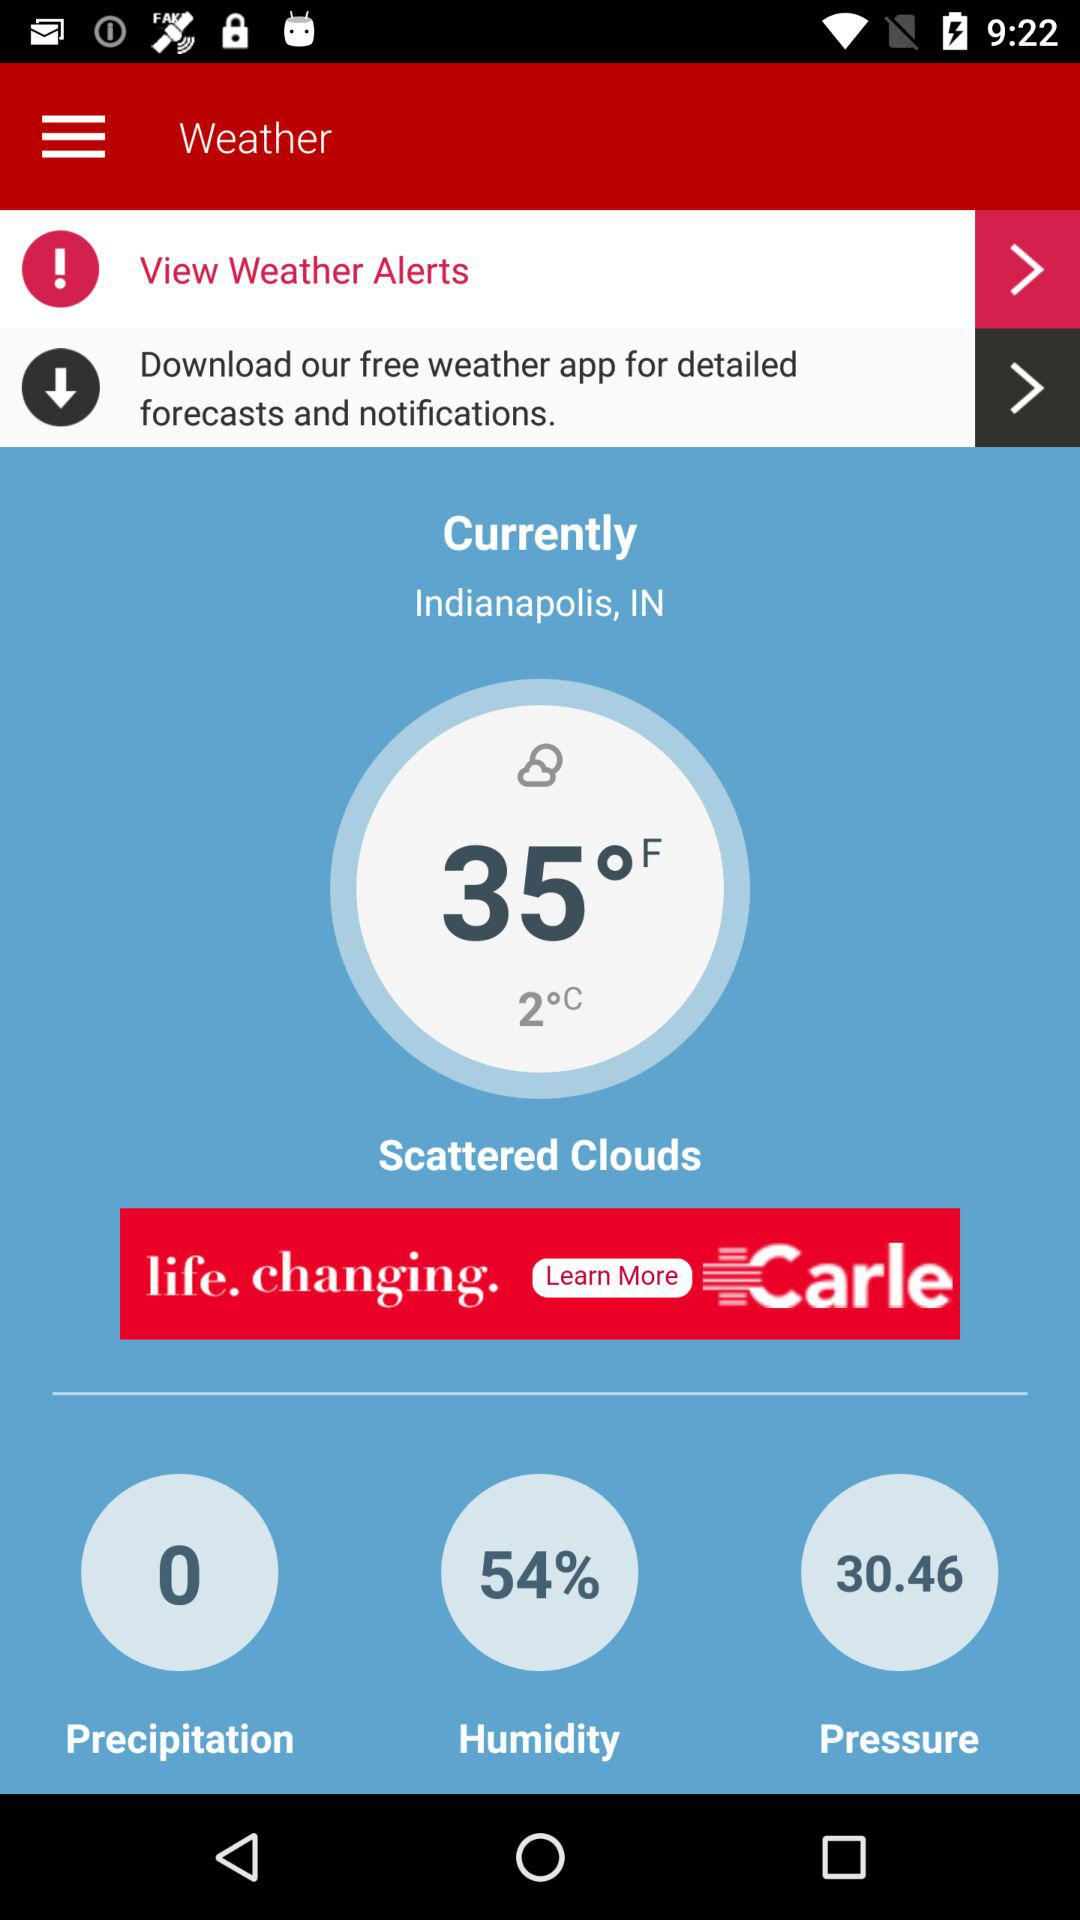What is the current location? The current location is Indianapolis, IN. 